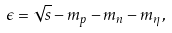<formula> <loc_0><loc_0><loc_500><loc_500>\epsilon = \sqrt { s } - m _ { p } - m _ { n } - m _ { \eta } ,</formula> 